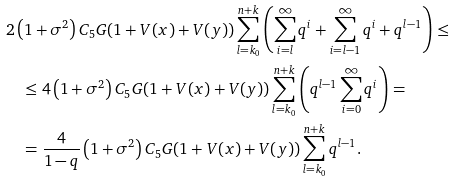Convert formula to latex. <formula><loc_0><loc_0><loc_500><loc_500>& 2 \left ( 1 + \sigma ^ { 2 } \right ) C _ { 5 } G ( 1 + V ( x ) + V ( y ) ) \sum _ { l = k _ { 0 } } ^ { n + k } \left ( \sum _ { i = l } ^ { \infty } q ^ { i } + \sum _ { i = l - 1 } ^ { \infty } q ^ { i } + q ^ { l - 1 } \right ) \leq \\ & \quad \leq 4 \left ( 1 + \sigma ^ { 2 } \right ) C _ { 5 } G ( 1 + V ( x ) + V ( y ) ) \sum _ { l = k _ { 0 } } ^ { n + k } \left ( q ^ { l - 1 } \sum _ { i = 0 } ^ { \infty } q ^ { i } \right ) = \\ & \quad = \frac { 4 } { 1 - q } \left ( 1 + \sigma ^ { 2 } \right ) C _ { 5 } G ( 1 + V ( x ) + V ( y ) ) \sum _ { l = k _ { 0 } } ^ { n + k } q ^ { l - 1 } .</formula> 